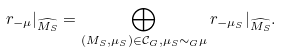Convert formula to latex. <formula><loc_0><loc_0><loc_500><loc_500>{ } r _ { - \mu } | _ { \widehat { M _ { S } } } = \bigoplus _ { ( M _ { S } , \mu _ { S } ) \in \mathcal { C } _ { G } , \mu _ { S } \sim _ { G } \mu } r _ { - \mu _ { S } } | _ { \widehat { M _ { S } } } .</formula> 